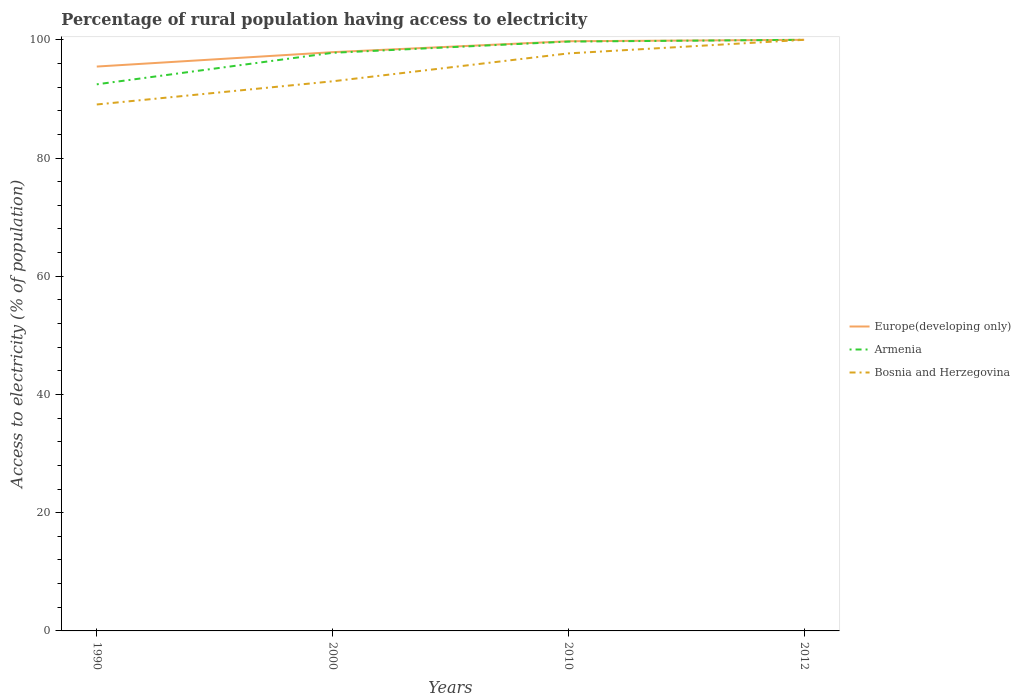How many different coloured lines are there?
Provide a short and direct response. 3. Does the line corresponding to Bosnia and Herzegovina intersect with the line corresponding to Armenia?
Offer a very short reply. Yes. Across all years, what is the maximum percentage of rural population having access to electricity in Armenia?
Your answer should be compact. 92.47. In which year was the percentage of rural population having access to electricity in Europe(developing only) maximum?
Offer a very short reply. 1990. What is the total percentage of rural population having access to electricity in Bosnia and Herzegovina in the graph?
Offer a terse response. -3.92. What is the difference between the highest and the second highest percentage of rural population having access to electricity in Bosnia and Herzegovina?
Keep it short and to the point. 10.94. How many lines are there?
Provide a short and direct response. 3. What is the difference between two consecutive major ticks on the Y-axis?
Provide a short and direct response. 20. What is the title of the graph?
Ensure brevity in your answer.  Percentage of rural population having access to electricity. What is the label or title of the Y-axis?
Your response must be concise. Access to electricity (% of population). What is the Access to electricity (% of population) in Europe(developing only) in 1990?
Keep it short and to the point. 95.48. What is the Access to electricity (% of population) of Armenia in 1990?
Your answer should be compact. 92.47. What is the Access to electricity (% of population) in Bosnia and Herzegovina in 1990?
Provide a short and direct response. 89.06. What is the Access to electricity (% of population) of Europe(developing only) in 2000?
Your response must be concise. 97.91. What is the Access to electricity (% of population) of Armenia in 2000?
Provide a short and direct response. 97.8. What is the Access to electricity (% of population) of Bosnia and Herzegovina in 2000?
Ensure brevity in your answer.  92.98. What is the Access to electricity (% of population) of Europe(developing only) in 2010?
Make the answer very short. 99.76. What is the Access to electricity (% of population) of Armenia in 2010?
Offer a terse response. 99.7. What is the Access to electricity (% of population) of Bosnia and Herzegovina in 2010?
Offer a very short reply. 97.7. What is the Access to electricity (% of population) in Armenia in 2012?
Give a very brief answer. 100. What is the Access to electricity (% of population) of Bosnia and Herzegovina in 2012?
Your answer should be very brief. 100. Across all years, what is the maximum Access to electricity (% of population) of Bosnia and Herzegovina?
Your response must be concise. 100. Across all years, what is the minimum Access to electricity (% of population) of Europe(developing only)?
Provide a short and direct response. 95.48. Across all years, what is the minimum Access to electricity (% of population) of Armenia?
Offer a very short reply. 92.47. Across all years, what is the minimum Access to electricity (% of population) of Bosnia and Herzegovina?
Provide a succinct answer. 89.06. What is the total Access to electricity (% of population) in Europe(developing only) in the graph?
Give a very brief answer. 393.14. What is the total Access to electricity (% of population) of Armenia in the graph?
Give a very brief answer. 389.97. What is the total Access to electricity (% of population) in Bosnia and Herzegovina in the graph?
Provide a succinct answer. 379.74. What is the difference between the Access to electricity (% of population) in Europe(developing only) in 1990 and that in 2000?
Offer a very short reply. -2.43. What is the difference between the Access to electricity (% of population) in Armenia in 1990 and that in 2000?
Your answer should be very brief. -5.33. What is the difference between the Access to electricity (% of population) of Bosnia and Herzegovina in 1990 and that in 2000?
Offer a very short reply. -3.92. What is the difference between the Access to electricity (% of population) of Europe(developing only) in 1990 and that in 2010?
Give a very brief answer. -4.28. What is the difference between the Access to electricity (% of population) of Armenia in 1990 and that in 2010?
Your response must be concise. -7.23. What is the difference between the Access to electricity (% of population) in Bosnia and Herzegovina in 1990 and that in 2010?
Offer a terse response. -8.64. What is the difference between the Access to electricity (% of population) in Europe(developing only) in 1990 and that in 2012?
Your response must be concise. -4.52. What is the difference between the Access to electricity (% of population) of Armenia in 1990 and that in 2012?
Your answer should be very brief. -7.53. What is the difference between the Access to electricity (% of population) of Bosnia and Herzegovina in 1990 and that in 2012?
Provide a short and direct response. -10.94. What is the difference between the Access to electricity (% of population) of Europe(developing only) in 2000 and that in 2010?
Give a very brief answer. -1.85. What is the difference between the Access to electricity (% of population) in Bosnia and Herzegovina in 2000 and that in 2010?
Make the answer very short. -4.72. What is the difference between the Access to electricity (% of population) in Europe(developing only) in 2000 and that in 2012?
Your response must be concise. -2.09. What is the difference between the Access to electricity (% of population) in Bosnia and Herzegovina in 2000 and that in 2012?
Provide a succinct answer. -7.02. What is the difference between the Access to electricity (% of population) in Europe(developing only) in 2010 and that in 2012?
Give a very brief answer. -0.24. What is the difference between the Access to electricity (% of population) of Europe(developing only) in 1990 and the Access to electricity (% of population) of Armenia in 2000?
Your response must be concise. -2.32. What is the difference between the Access to electricity (% of population) of Europe(developing only) in 1990 and the Access to electricity (% of population) of Bosnia and Herzegovina in 2000?
Your answer should be very brief. 2.49. What is the difference between the Access to electricity (% of population) in Armenia in 1990 and the Access to electricity (% of population) in Bosnia and Herzegovina in 2000?
Give a very brief answer. -0.51. What is the difference between the Access to electricity (% of population) of Europe(developing only) in 1990 and the Access to electricity (% of population) of Armenia in 2010?
Ensure brevity in your answer.  -4.22. What is the difference between the Access to electricity (% of population) in Europe(developing only) in 1990 and the Access to electricity (% of population) in Bosnia and Herzegovina in 2010?
Provide a succinct answer. -2.22. What is the difference between the Access to electricity (% of population) of Armenia in 1990 and the Access to electricity (% of population) of Bosnia and Herzegovina in 2010?
Provide a succinct answer. -5.23. What is the difference between the Access to electricity (% of population) of Europe(developing only) in 1990 and the Access to electricity (% of population) of Armenia in 2012?
Make the answer very short. -4.52. What is the difference between the Access to electricity (% of population) of Europe(developing only) in 1990 and the Access to electricity (% of population) of Bosnia and Herzegovina in 2012?
Ensure brevity in your answer.  -4.52. What is the difference between the Access to electricity (% of population) of Armenia in 1990 and the Access to electricity (% of population) of Bosnia and Herzegovina in 2012?
Your response must be concise. -7.53. What is the difference between the Access to electricity (% of population) in Europe(developing only) in 2000 and the Access to electricity (% of population) in Armenia in 2010?
Your answer should be very brief. -1.79. What is the difference between the Access to electricity (% of population) of Europe(developing only) in 2000 and the Access to electricity (% of population) of Bosnia and Herzegovina in 2010?
Your answer should be compact. 0.21. What is the difference between the Access to electricity (% of population) in Armenia in 2000 and the Access to electricity (% of population) in Bosnia and Herzegovina in 2010?
Your answer should be compact. 0.1. What is the difference between the Access to electricity (% of population) in Europe(developing only) in 2000 and the Access to electricity (% of population) in Armenia in 2012?
Make the answer very short. -2.09. What is the difference between the Access to electricity (% of population) of Europe(developing only) in 2000 and the Access to electricity (% of population) of Bosnia and Herzegovina in 2012?
Ensure brevity in your answer.  -2.09. What is the difference between the Access to electricity (% of population) of Europe(developing only) in 2010 and the Access to electricity (% of population) of Armenia in 2012?
Give a very brief answer. -0.24. What is the difference between the Access to electricity (% of population) in Europe(developing only) in 2010 and the Access to electricity (% of population) in Bosnia and Herzegovina in 2012?
Your response must be concise. -0.24. What is the average Access to electricity (% of population) of Europe(developing only) per year?
Give a very brief answer. 98.28. What is the average Access to electricity (% of population) of Armenia per year?
Ensure brevity in your answer.  97.49. What is the average Access to electricity (% of population) in Bosnia and Herzegovina per year?
Make the answer very short. 94.94. In the year 1990, what is the difference between the Access to electricity (% of population) in Europe(developing only) and Access to electricity (% of population) in Armenia?
Make the answer very short. 3.01. In the year 1990, what is the difference between the Access to electricity (% of population) in Europe(developing only) and Access to electricity (% of population) in Bosnia and Herzegovina?
Ensure brevity in your answer.  6.42. In the year 1990, what is the difference between the Access to electricity (% of population) of Armenia and Access to electricity (% of population) of Bosnia and Herzegovina?
Give a very brief answer. 3.41. In the year 2000, what is the difference between the Access to electricity (% of population) of Europe(developing only) and Access to electricity (% of population) of Armenia?
Give a very brief answer. 0.11. In the year 2000, what is the difference between the Access to electricity (% of population) in Europe(developing only) and Access to electricity (% of population) in Bosnia and Herzegovina?
Make the answer very short. 4.93. In the year 2000, what is the difference between the Access to electricity (% of population) of Armenia and Access to electricity (% of population) of Bosnia and Herzegovina?
Your response must be concise. 4.82. In the year 2010, what is the difference between the Access to electricity (% of population) in Europe(developing only) and Access to electricity (% of population) in Armenia?
Ensure brevity in your answer.  0.06. In the year 2010, what is the difference between the Access to electricity (% of population) in Europe(developing only) and Access to electricity (% of population) in Bosnia and Herzegovina?
Your answer should be very brief. 2.06. In the year 2012, what is the difference between the Access to electricity (% of population) in Europe(developing only) and Access to electricity (% of population) in Armenia?
Provide a short and direct response. 0. In the year 2012, what is the difference between the Access to electricity (% of population) in Europe(developing only) and Access to electricity (% of population) in Bosnia and Herzegovina?
Make the answer very short. 0. In the year 2012, what is the difference between the Access to electricity (% of population) in Armenia and Access to electricity (% of population) in Bosnia and Herzegovina?
Your answer should be compact. 0. What is the ratio of the Access to electricity (% of population) in Europe(developing only) in 1990 to that in 2000?
Your answer should be very brief. 0.98. What is the ratio of the Access to electricity (% of population) in Armenia in 1990 to that in 2000?
Make the answer very short. 0.95. What is the ratio of the Access to electricity (% of population) in Bosnia and Herzegovina in 1990 to that in 2000?
Ensure brevity in your answer.  0.96. What is the ratio of the Access to electricity (% of population) of Europe(developing only) in 1990 to that in 2010?
Give a very brief answer. 0.96. What is the ratio of the Access to electricity (% of population) in Armenia in 1990 to that in 2010?
Your response must be concise. 0.93. What is the ratio of the Access to electricity (% of population) of Bosnia and Herzegovina in 1990 to that in 2010?
Make the answer very short. 0.91. What is the ratio of the Access to electricity (% of population) of Europe(developing only) in 1990 to that in 2012?
Keep it short and to the point. 0.95. What is the ratio of the Access to electricity (% of population) of Armenia in 1990 to that in 2012?
Keep it short and to the point. 0.92. What is the ratio of the Access to electricity (% of population) of Bosnia and Herzegovina in 1990 to that in 2012?
Ensure brevity in your answer.  0.89. What is the ratio of the Access to electricity (% of population) in Europe(developing only) in 2000 to that in 2010?
Keep it short and to the point. 0.98. What is the ratio of the Access to electricity (% of population) of Armenia in 2000 to that in 2010?
Your response must be concise. 0.98. What is the ratio of the Access to electricity (% of population) in Bosnia and Herzegovina in 2000 to that in 2010?
Offer a very short reply. 0.95. What is the ratio of the Access to electricity (% of population) in Europe(developing only) in 2000 to that in 2012?
Ensure brevity in your answer.  0.98. What is the ratio of the Access to electricity (% of population) of Bosnia and Herzegovina in 2000 to that in 2012?
Offer a very short reply. 0.93. What is the ratio of the Access to electricity (% of population) in Armenia in 2010 to that in 2012?
Ensure brevity in your answer.  1. What is the difference between the highest and the second highest Access to electricity (% of population) in Europe(developing only)?
Provide a succinct answer. 0.24. What is the difference between the highest and the second highest Access to electricity (% of population) in Armenia?
Offer a very short reply. 0.3. What is the difference between the highest and the second highest Access to electricity (% of population) of Bosnia and Herzegovina?
Offer a terse response. 2.3. What is the difference between the highest and the lowest Access to electricity (% of population) in Europe(developing only)?
Offer a very short reply. 4.52. What is the difference between the highest and the lowest Access to electricity (% of population) of Armenia?
Ensure brevity in your answer.  7.53. What is the difference between the highest and the lowest Access to electricity (% of population) of Bosnia and Herzegovina?
Keep it short and to the point. 10.94. 